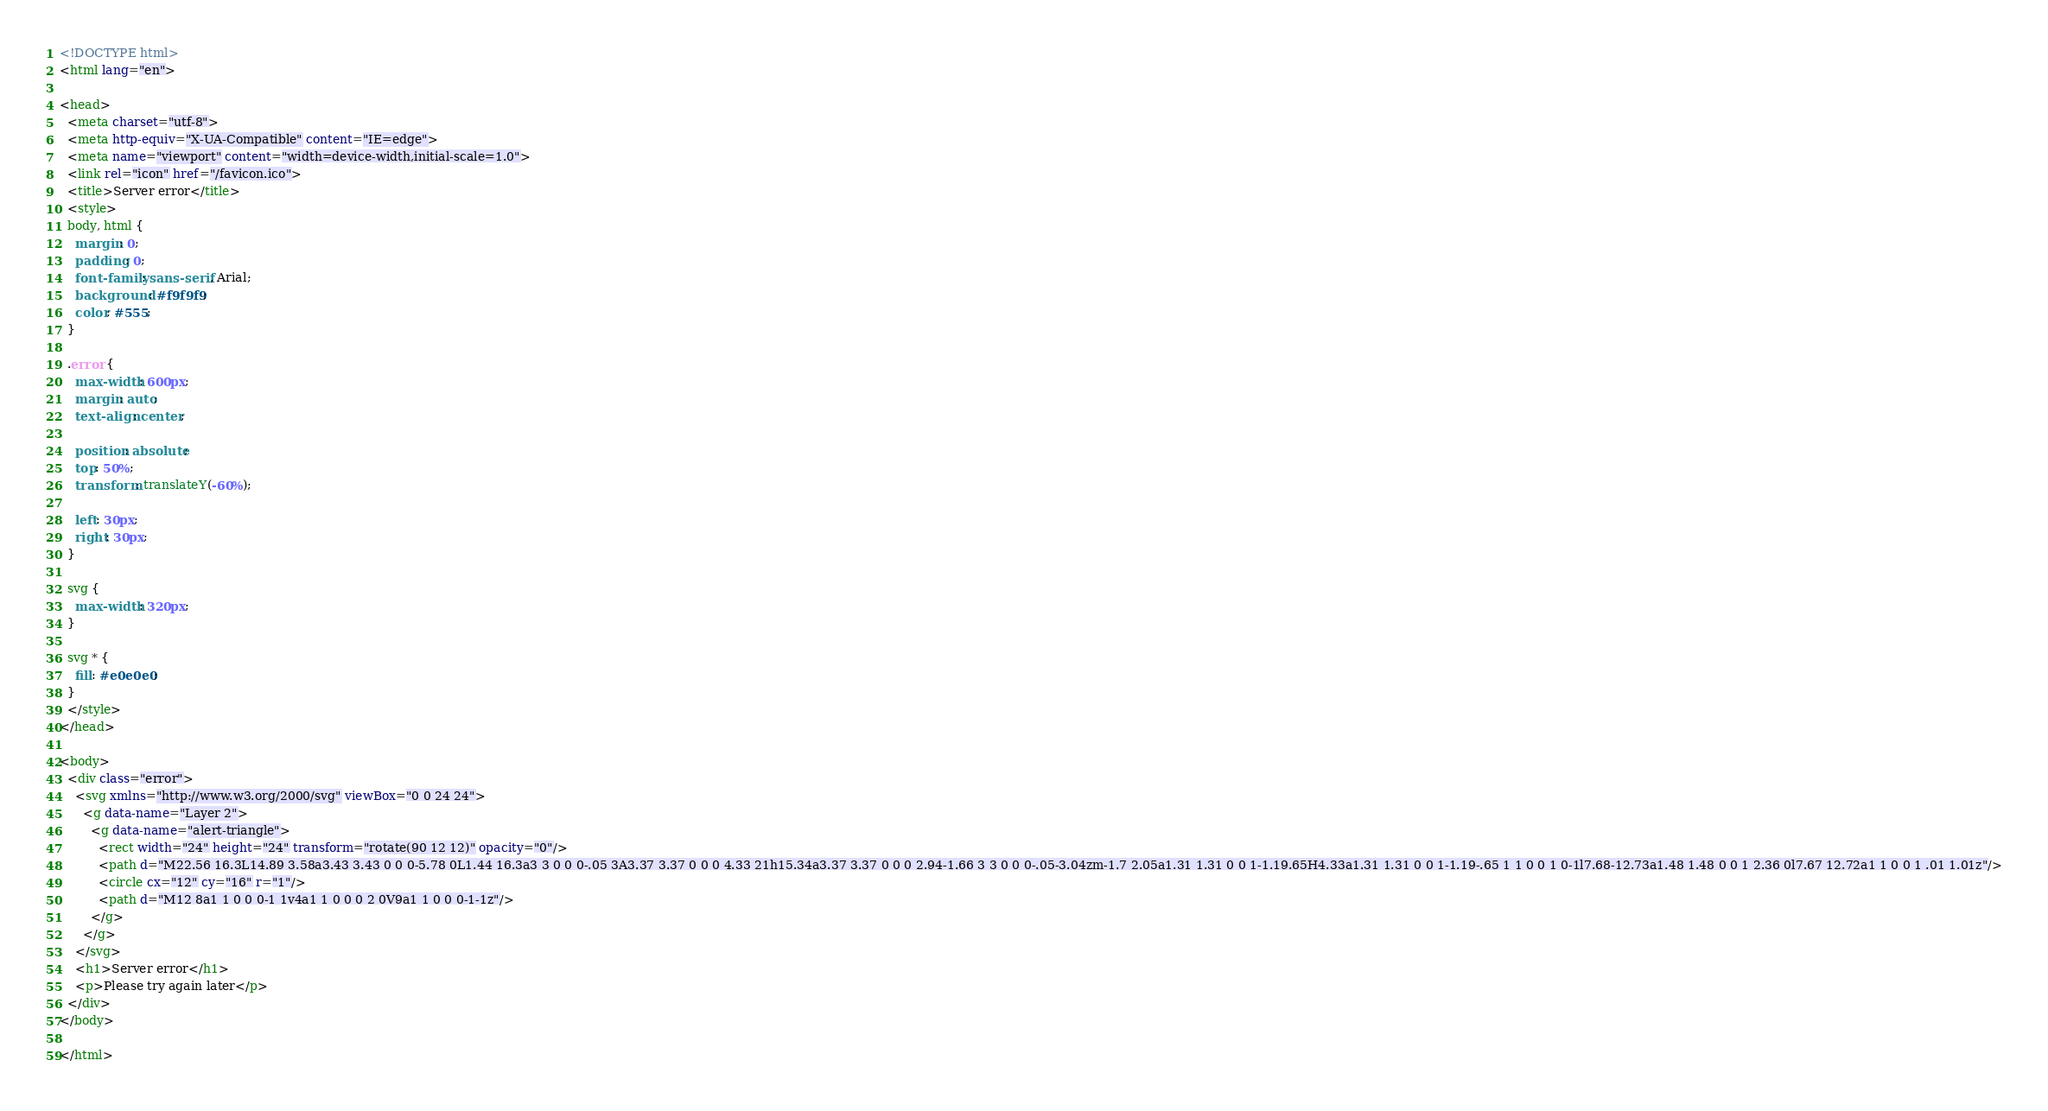Convert code to text. <code><loc_0><loc_0><loc_500><loc_500><_HTML_><!DOCTYPE html>
<html lang="en">

<head>
  <meta charset="utf-8">
  <meta http-equiv="X-UA-Compatible" content="IE=edge">
  <meta name="viewport" content="width=device-width,initial-scale=1.0">
  <link rel="icon" href="/favicon.ico">
  <title>Server error</title>
  <style>
  body, html {
    margin: 0;
    padding: 0;
    font-family: sans-serif, Arial;
    background: #f9f9f9;
    color: #555;
  }

  .error {
    max-width: 600px;
    margin: auto;
    text-align: center;

    position: absolute;
    top: 50%;
    transform: translateY(-60%);

    left: 30px;
    right: 30px;
  }

  svg {
    max-width: 320px;
  }

  svg * {
    fill: #e0e0e0;
  }
  </style>
</head>

<body>
  <div class="error">
    <svg xmlns="http://www.w3.org/2000/svg" viewBox="0 0 24 24">
      <g data-name="Layer 2">
        <g data-name="alert-triangle">
          <rect width="24" height="24" transform="rotate(90 12 12)" opacity="0"/>
          <path d="M22.56 16.3L14.89 3.58a3.43 3.43 0 0 0-5.78 0L1.44 16.3a3 3 0 0 0-.05 3A3.37 3.37 0 0 0 4.33 21h15.34a3.37 3.37 0 0 0 2.94-1.66 3 3 0 0 0-.05-3.04zm-1.7 2.05a1.31 1.31 0 0 1-1.19.65H4.33a1.31 1.31 0 0 1-1.19-.65 1 1 0 0 1 0-1l7.68-12.73a1.48 1.48 0 0 1 2.36 0l7.67 12.72a1 1 0 0 1 .01 1.01z"/>
          <circle cx="12" cy="16" r="1"/>
          <path d="M12 8a1 1 0 0 0-1 1v4a1 1 0 0 0 2 0V9a1 1 0 0 0-1-1z"/>
        </g>
      </g>
    </svg>
    <h1>Server error</h1>
    <p>Please try again later</p>
  </div>
</body>

</html>
</code> 